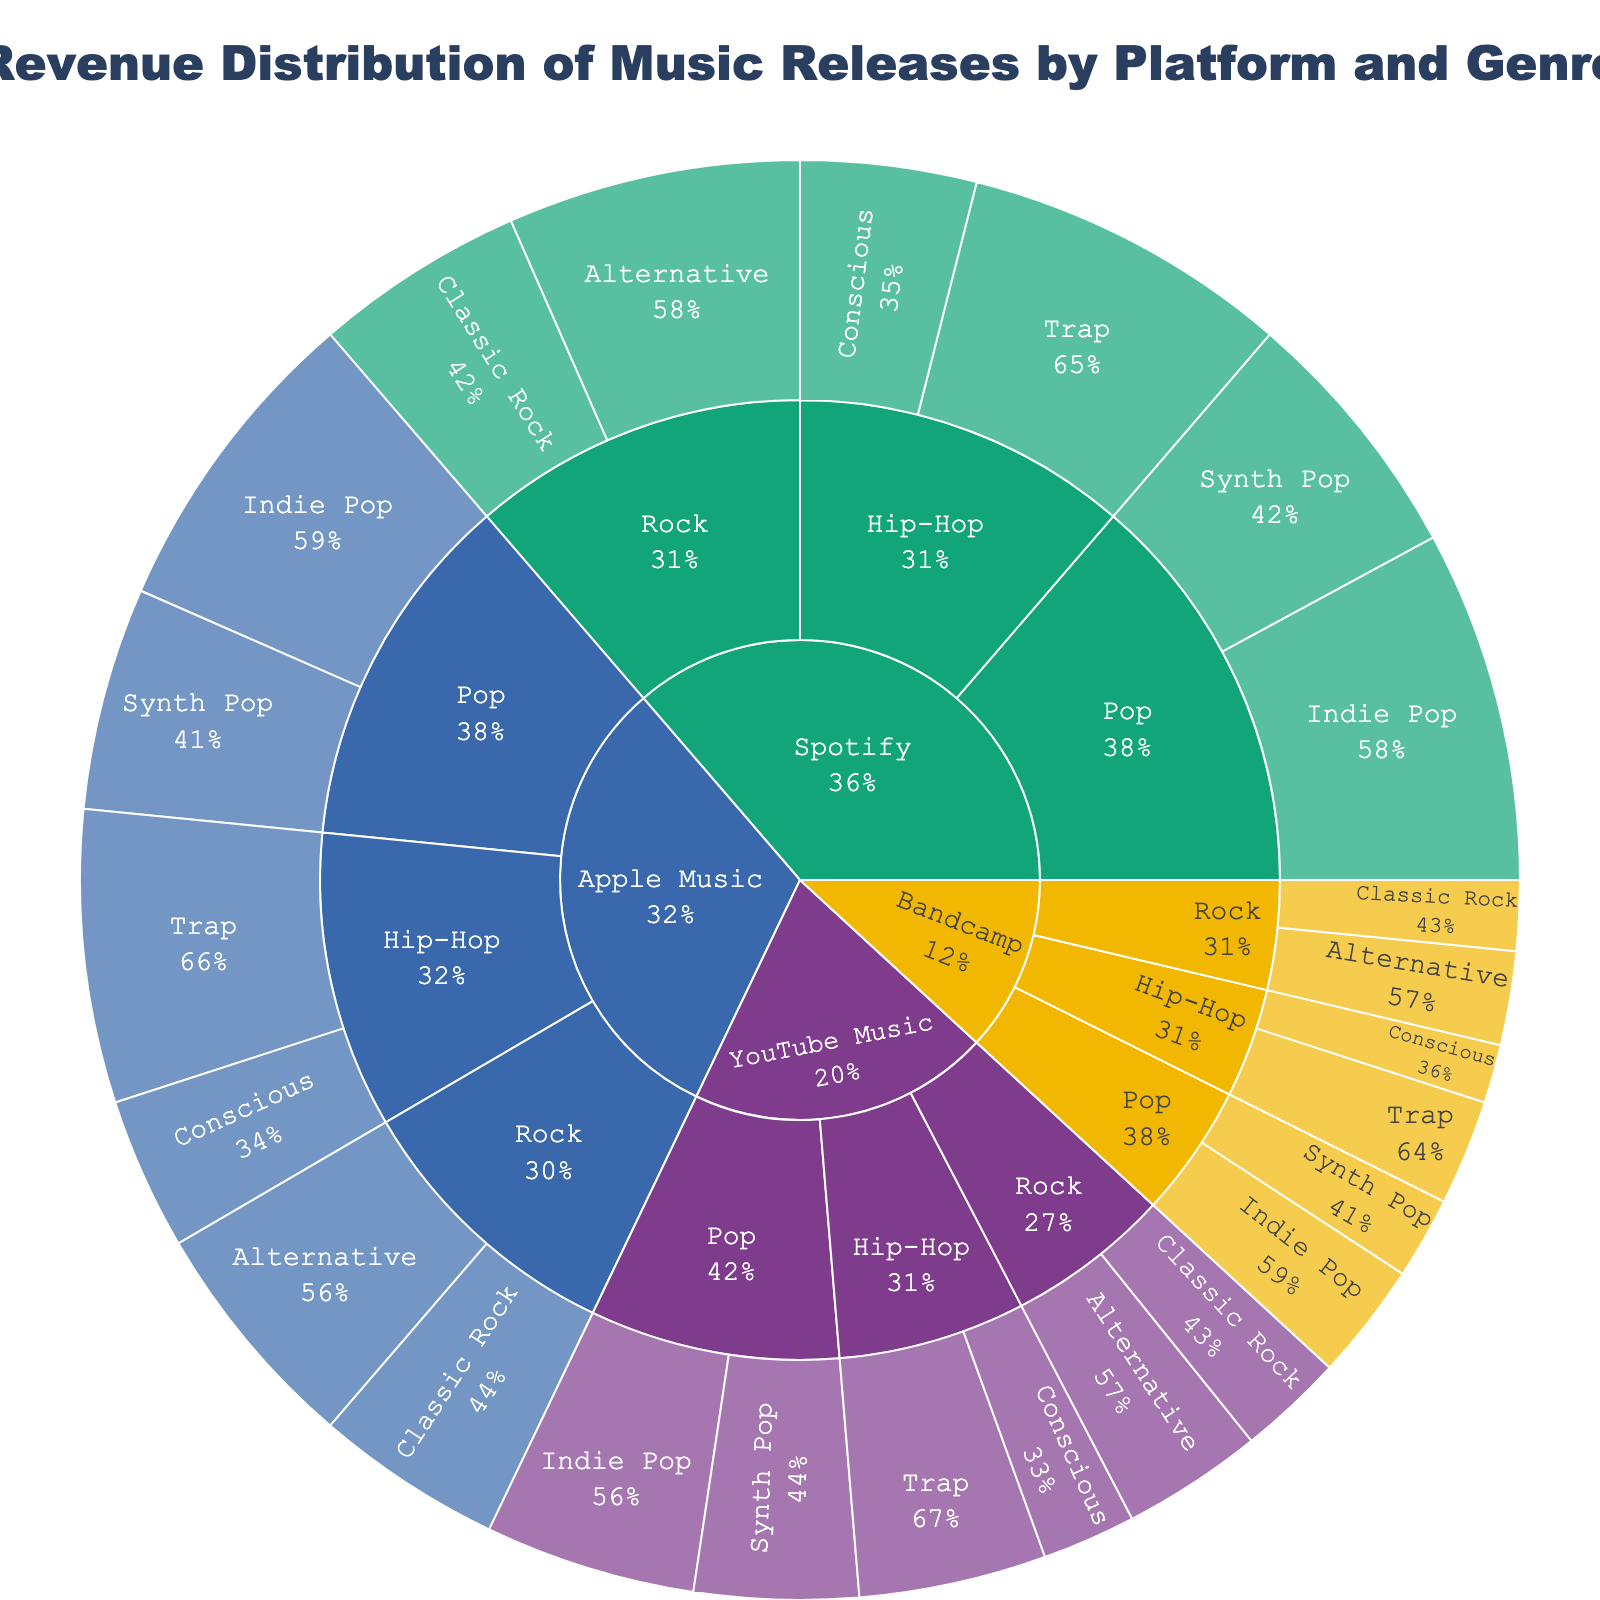What is the title of the sunburst plot? The title is located at the top center of the plot, which summarizes the entire figure.
Answer: Revenue Distribution of Music Releases by Platform and Genre Which platform has the highest total revenue in the plot? Sum up the revenues for each platform and compare the totals. Spotify: $1,380,000, Apple Music: $1,200,000, YouTube Music: $670,000, Bandcamp: $450,000. Spotify has the highest total.
Answer: Spotify What is the combined revenue for the Pop genre across all platforms? Add up the revenues for Pop sub-genres (Indie Pop and Synth Pop) across all platforms. ($300,000 + $220,000 + $270,000 + $190,000 + $180,000 + $140,000 + $100,000 + $70,000)
Answer: $1,470,000 Which sub-genre of Rock on Spotify has more revenue, Alternative or Classic Rock? Compare the revenue of Rock sub-genres on Spotify: Alternative ($250,000) vs Classic Rock ($180,000). Alternative has more revenue.
Answer: Alternative How does the revenue of Trap sub-genre on Apple Music compare to YouTube Music? Compare the revenue of Trap on Apple Music ($250,000) and YouTube Music ($160,000). Apple Music has higher revenue.
Answer: Apple Music has higher revenue What percentage of Spotify's total revenue comes from the Indie Pop sub-genre under Pop? Calculate Spotify total revenue and the portion from Indie Pop, then compute the percentage. (Spotify Indie Pop: $300,000) / (Spotify total revenue: $1,380,000) * 100% ≈ 21.7%
Answer: 21.7% What is the total revenue for all Hip-Hop music across all platforms? Add up revenues for Hip-Hop sub-genres (Conscious and Trap) across all platforms. ($150,000 + $280,000 + $130,000 + $250,000 + $80,000 + $160,000 + $50,000 + $90,000)
Answer: $1,190,000 Which genre on YouTube Music has the lowest revenue? Compare the revenues of Alternative Rock ($120,000), Classic Rock ($90,000), Indie Pop ($180,000), Synth Pop ($140,000), Conscious Hip-Hop ($80,000), and Trap ($160,000). Classic Rock has the lowest revenue.
Answer: Classic Rock How does the revenue of the Pop genre on Bandcamp compare to that on Apple Music? Compare the total pop revenue on Bandcamp ($100,000 + $70,000 = $170,000) to that on Apple Music ($270,000 + $190,000 = $460,000). Bandcamp has lower revenue.
Answer: Bandcamp has lower revenue What is the revenue difference between Alternative Rock and Classic Rock on YouTube Music? Subtract the revenue of Classic Rock ($90,000) from that of Alternative Rock ($120,000) on YouTube Music. $120,000 - $90,000 = $30,000.
Answer: $30,000 